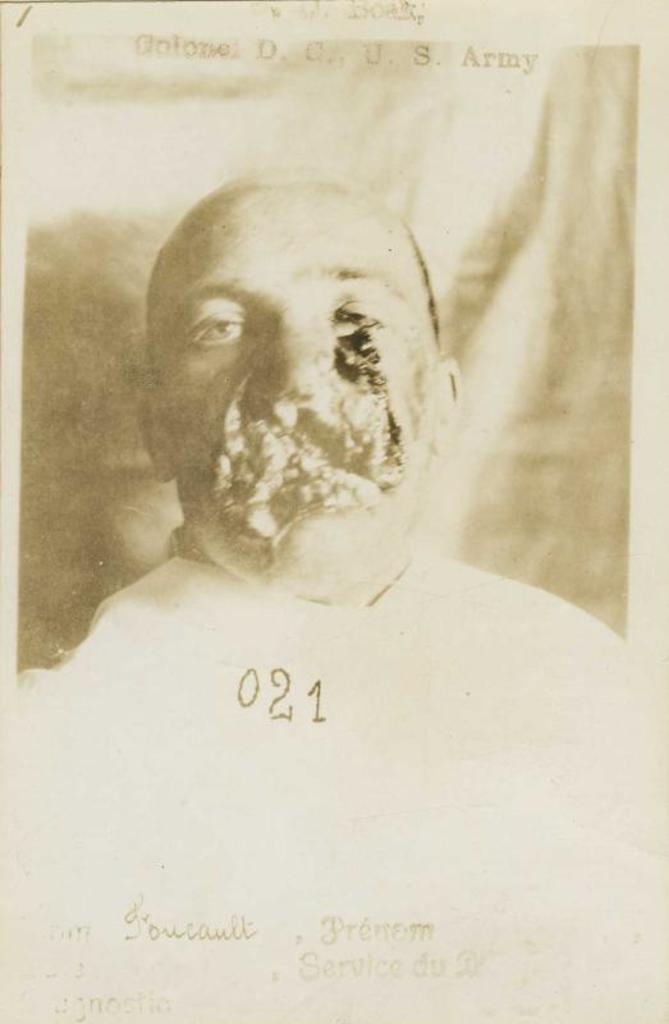How would you summarize this image in a sentence or two? This image is a picture of a man. He is wearing a white shirt. 